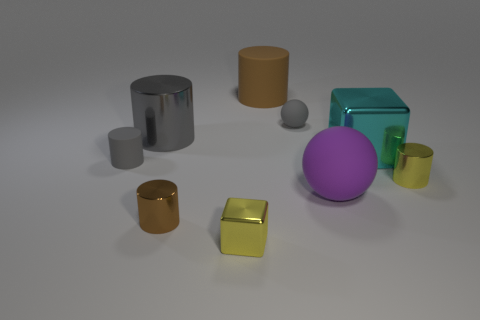The yellow cylinder is what size? The yellow cylinder appears to be of medium size when compared to the other objects in the image, such as the larger purple sphere and the smaller grey cylinder. 